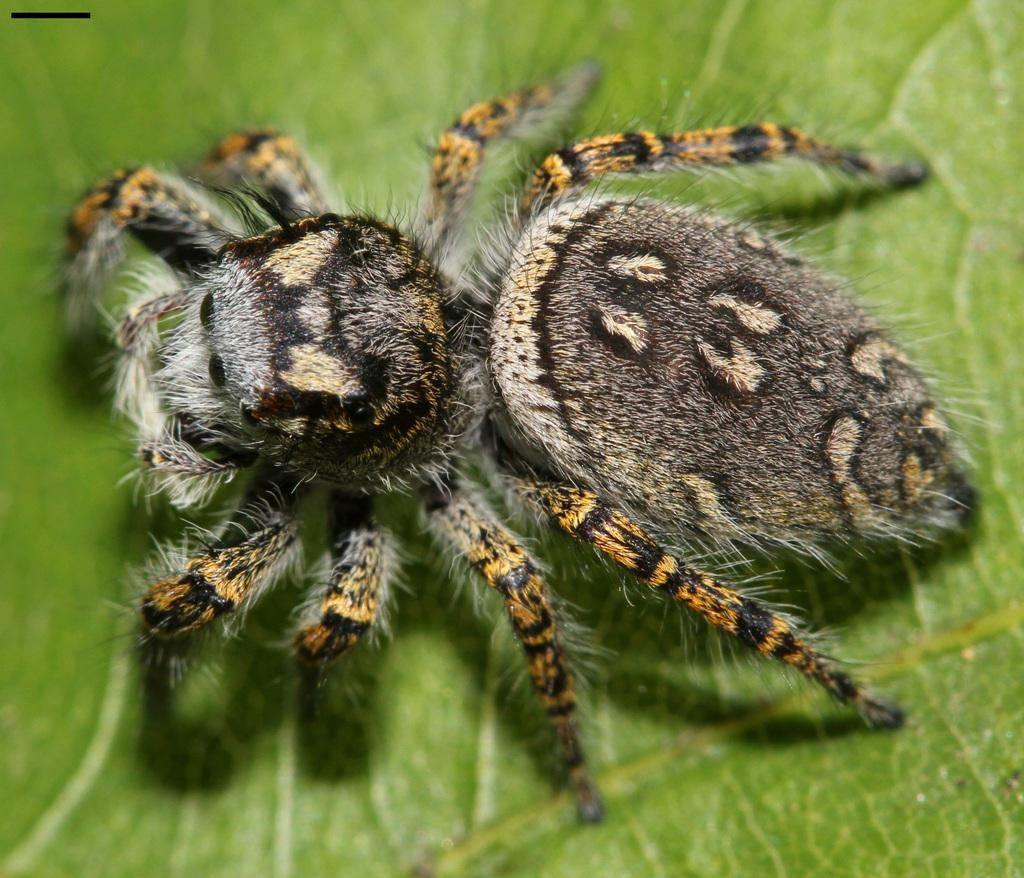What is present on the green leaf in the image? There is an insect on the green leaf in the image. What colors can be seen on the insect? The insect has black, white, and brown colors. What type of bears can be seen eating cabbage in the image? There are no bears or cabbage present in the image; it features an insect on a green leaf. Can you describe the cat's behavior in the image? There is no cat present in the image; it features an insect on a green leaf. 